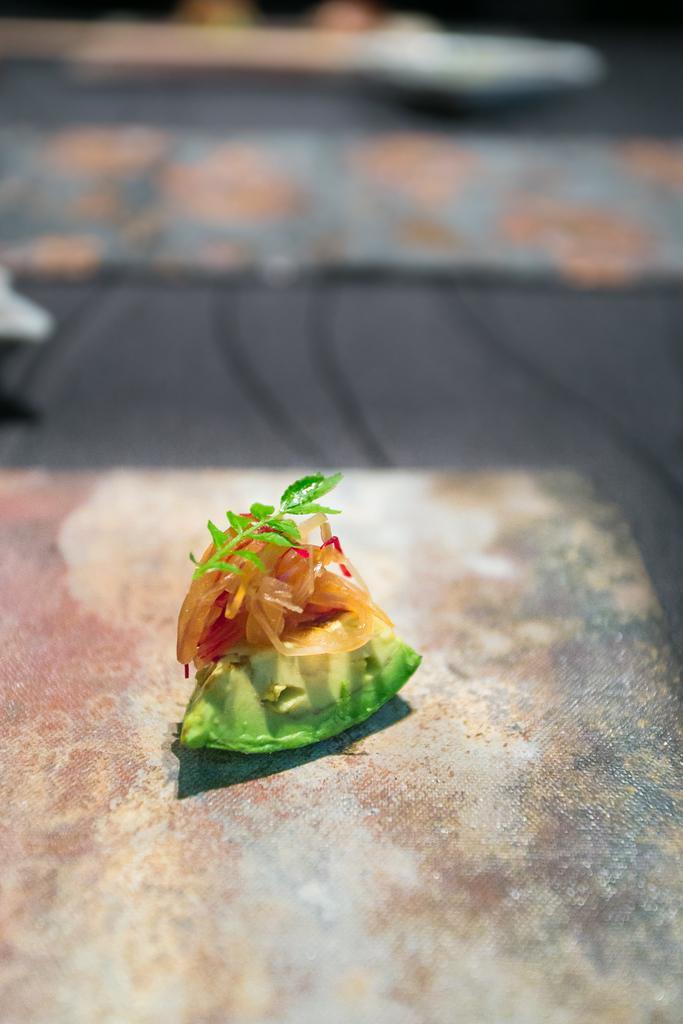Can you describe this image briefly? In the middle of this image, there is a stem having green color leaves on the ingredients. These ingredients on a fruit. This fruit is on a surface. And the background is blurred. 